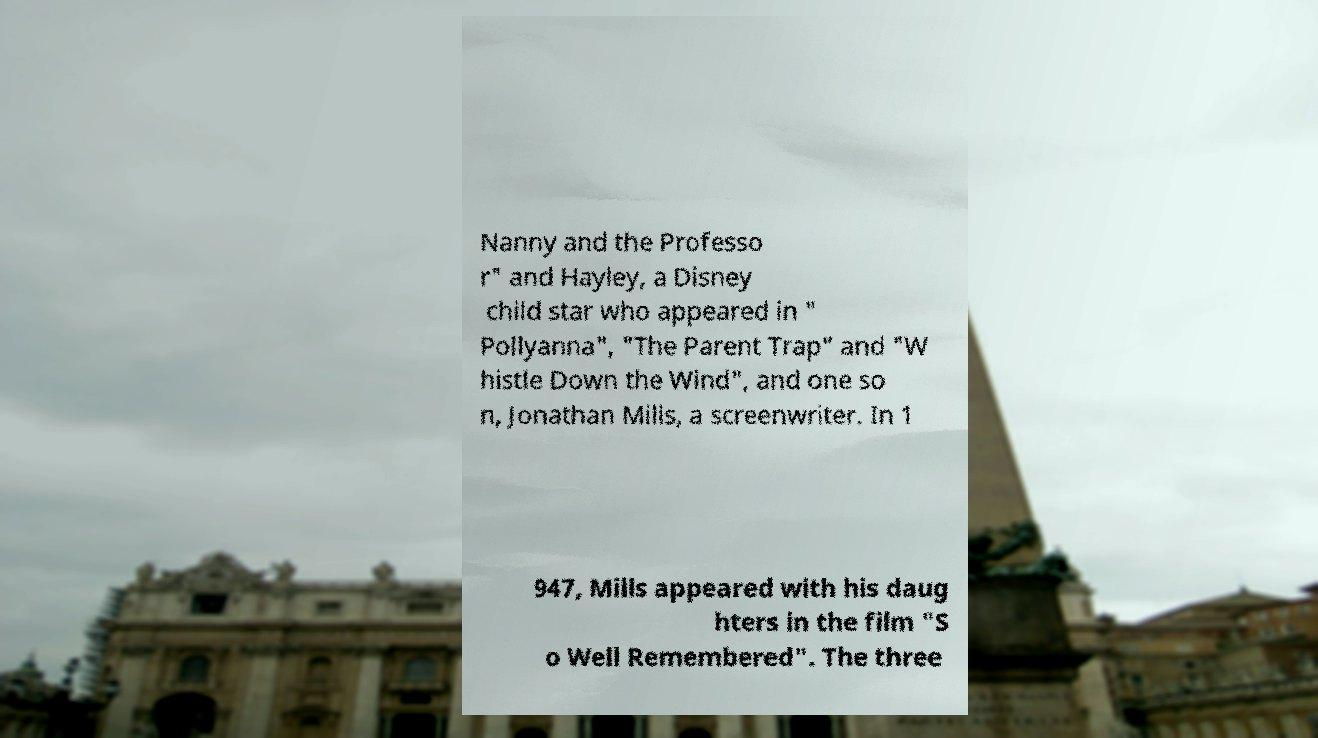For documentation purposes, I need the text within this image transcribed. Could you provide that? Nanny and the Professo r" and Hayley, a Disney child star who appeared in " Pollyanna", "The Parent Trap" and "W histle Down the Wind", and one so n, Jonathan Mills, a screenwriter. In 1 947, Mills appeared with his daug hters in the film "S o Well Remembered". The three 